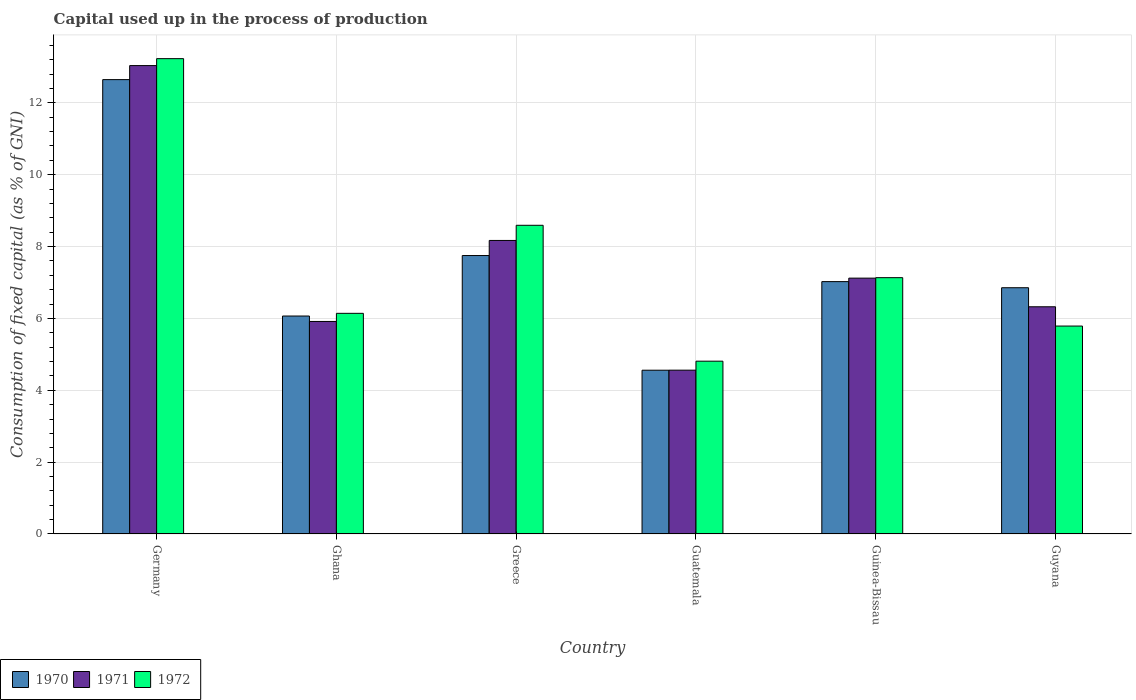How many groups of bars are there?
Offer a very short reply. 6. Are the number of bars per tick equal to the number of legend labels?
Give a very brief answer. Yes. Are the number of bars on each tick of the X-axis equal?
Provide a succinct answer. Yes. How many bars are there on the 2nd tick from the left?
Your answer should be compact. 3. How many bars are there on the 4th tick from the right?
Keep it short and to the point. 3. What is the label of the 5th group of bars from the left?
Your response must be concise. Guinea-Bissau. In how many cases, is the number of bars for a given country not equal to the number of legend labels?
Provide a short and direct response. 0. What is the capital used up in the process of production in 1970 in Germany?
Offer a terse response. 12.65. Across all countries, what is the maximum capital used up in the process of production in 1972?
Ensure brevity in your answer.  13.23. Across all countries, what is the minimum capital used up in the process of production in 1970?
Provide a succinct answer. 4.56. In which country was the capital used up in the process of production in 1970 minimum?
Make the answer very short. Guatemala. What is the total capital used up in the process of production in 1971 in the graph?
Ensure brevity in your answer.  45.13. What is the difference between the capital used up in the process of production in 1972 in Guinea-Bissau and that in Guyana?
Offer a very short reply. 1.35. What is the difference between the capital used up in the process of production in 1970 in Guyana and the capital used up in the process of production in 1972 in Guinea-Bissau?
Your response must be concise. -0.28. What is the average capital used up in the process of production in 1971 per country?
Offer a terse response. 7.52. What is the difference between the capital used up in the process of production of/in 1970 and capital used up in the process of production of/in 1972 in Ghana?
Your response must be concise. -0.07. What is the ratio of the capital used up in the process of production in 1971 in Germany to that in Guyana?
Offer a very short reply. 2.06. Is the difference between the capital used up in the process of production in 1970 in Greece and Guinea-Bissau greater than the difference between the capital used up in the process of production in 1972 in Greece and Guinea-Bissau?
Your response must be concise. No. What is the difference between the highest and the second highest capital used up in the process of production in 1970?
Keep it short and to the point. 5.62. What is the difference between the highest and the lowest capital used up in the process of production in 1972?
Make the answer very short. 8.42. Is the sum of the capital used up in the process of production in 1972 in Guinea-Bissau and Guyana greater than the maximum capital used up in the process of production in 1970 across all countries?
Your answer should be very brief. Yes. What does the 3rd bar from the left in Guinea-Bissau represents?
Keep it short and to the point. 1972. What does the 1st bar from the right in Guinea-Bissau represents?
Your answer should be compact. 1972. Is it the case that in every country, the sum of the capital used up in the process of production in 1970 and capital used up in the process of production in 1972 is greater than the capital used up in the process of production in 1971?
Keep it short and to the point. Yes. How many bars are there?
Make the answer very short. 18. What is the difference between two consecutive major ticks on the Y-axis?
Your answer should be compact. 2. Are the values on the major ticks of Y-axis written in scientific E-notation?
Make the answer very short. No. Does the graph contain any zero values?
Your answer should be very brief. No. Does the graph contain grids?
Make the answer very short. Yes. Where does the legend appear in the graph?
Your answer should be compact. Bottom left. What is the title of the graph?
Provide a short and direct response. Capital used up in the process of production. What is the label or title of the X-axis?
Provide a short and direct response. Country. What is the label or title of the Y-axis?
Your answer should be very brief. Consumption of fixed capital (as % of GNI). What is the Consumption of fixed capital (as % of GNI) of 1970 in Germany?
Make the answer very short. 12.65. What is the Consumption of fixed capital (as % of GNI) in 1971 in Germany?
Your response must be concise. 13.04. What is the Consumption of fixed capital (as % of GNI) of 1972 in Germany?
Give a very brief answer. 13.23. What is the Consumption of fixed capital (as % of GNI) of 1970 in Ghana?
Provide a succinct answer. 6.07. What is the Consumption of fixed capital (as % of GNI) of 1971 in Ghana?
Your response must be concise. 5.92. What is the Consumption of fixed capital (as % of GNI) of 1972 in Ghana?
Provide a short and direct response. 6.14. What is the Consumption of fixed capital (as % of GNI) in 1970 in Greece?
Offer a terse response. 7.75. What is the Consumption of fixed capital (as % of GNI) of 1971 in Greece?
Provide a succinct answer. 8.17. What is the Consumption of fixed capital (as % of GNI) of 1972 in Greece?
Give a very brief answer. 8.59. What is the Consumption of fixed capital (as % of GNI) in 1970 in Guatemala?
Offer a very short reply. 4.56. What is the Consumption of fixed capital (as % of GNI) in 1971 in Guatemala?
Ensure brevity in your answer.  4.56. What is the Consumption of fixed capital (as % of GNI) in 1972 in Guatemala?
Offer a very short reply. 4.81. What is the Consumption of fixed capital (as % of GNI) in 1970 in Guinea-Bissau?
Provide a succinct answer. 7.02. What is the Consumption of fixed capital (as % of GNI) in 1971 in Guinea-Bissau?
Offer a terse response. 7.12. What is the Consumption of fixed capital (as % of GNI) in 1972 in Guinea-Bissau?
Make the answer very short. 7.13. What is the Consumption of fixed capital (as % of GNI) of 1970 in Guyana?
Provide a succinct answer. 6.85. What is the Consumption of fixed capital (as % of GNI) in 1971 in Guyana?
Keep it short and to the point. 6.32. What is the Consumption of fixed capital (as % of GNI) in 1972 in Guyana?
Your answer should be compact. 5.79. Across all countries, what is the maximum Consumption of fixed capital (as % of GNI) of 1970?
Your response must be concise. 12.65. Across all countries, what is the maximum Consumption of fixed capital (as % of GNI) of 1971?
Offer a very short reply. 13.04. Across all countries, what is the maximum Consumption of fixed capital (as % of GNI) of 1972?
Offer a terse response. 13.23. Across all countries, what is the minimum Consumption of fixed capital (as % of GNI) in 1970?
Make the answer very short. 4.56. Across all countries, what is the minimum Consumption of fixed capital (as % of GNI) of 1971?
Ensure brevity in your answer.  4.56. Across all countries, what is the minimum Consumption of fixed capital (as % of GNI) of 1972?
Make the answer very short. 4.81. What is the total Consumption of fixed capital (as % of GNI) of 1970 in the graph?
Provide a short and direct response. 44.9. What is the total Consumption of fixed capital (as % of GNI) of 1971 in the graph?
Offer a very short reply. 45.13. What is the total Consumption of fixed capital (as % of GNI) in 1972 in the graph?
Your answer should be compact. 45.7. What is the difference between the Consumption of fixed capital (as % of GNI) in 1970 in Germany and that in Ghana?
Your answer should be very brief. 6.58. What is the difference between the Consumption of fixed capital (as % of GNI) in 1971 in Germany and that in Ghana?
Ensure brevity in your answer.  7.12. What is the difference between the Consumption of fixed capital (as % of GNI) of 1972 in Germany and that in Ghana?
Your answer should be very brief. 7.09. What is the difference between the Consumption of fixed capital (as % of GNI) of 1970 in Germany and that in Greece?
Offer a very short reply. 4.9. What is the difference between the Consumption of fixed capital (as % of GNI) in 1971 in Germany and that in Greece?
Ensure brevity in your answer.  4.87. What is the difference between the Consumption of fixed capital (as % of GNI) of 1972 in Germany and that in Greece?
Provide a short and direct response. 4.64. What is the difference between the Consumption of fixed capital (as % of GNI) of 1970 in Germany and that in Guatemala?
Ensure brevity in your answer.  8.09. What is the difference between the Consumption of fixed capital (as % of GNI) of 1971 in Germany and that in Guatemala?
Your answer should be compact. 8.48. What is the difference between the Consumption of fixed capital (as % of GNI) of 1972 in Germany and that in Guatemala?
Your response must be concise. 8.42. What is the difference between the Consumption of fixed capital (as % of GNI) of 1970 in Germany and that in Guinea-Bissau?
Your answer should be compact. 5.62. What is the difference between the Consumption of fixed capital (as % of GNI) in 1971 in Germany and that in Guinea-Bissau?
Your response must be concise. 5.92. What is the difference between the Consumption of fixed capital (as % of GNI) of 1972 in Germany and that in Guinea-Bissau?
Make the answer very short. 6.1. What is the difference between the Consumption of fixed capital (as % of GNI) in 1970 in Germany and that in Guyana?
Your answer should be compact. 5.79. What is the difference between the Consumption of fixed capital (as % of GNI) in 1971 in Germany and that in Guyana?
Your response must be concise. 6.71. What is the difference between the Consumption of fixed capital (as % of GNI) in 1972 in Germany and that in Guyana?
Your answer should be compact. 7.44. What is the difference between the Consumption of fixed capital (as % of GNI) of 1970 in Ghana and that in Greece?
Offer a terse response. -1.68. What is the difference between the Consumption of fixed capital (as % of GNI) of 1971 in Ghana and that in Greece?
Your response must be concise. -2.25. What is the difference between the Consumption of fixed capital (as % of GNI) of 1972 in Ghana and that in Greece?
Offer a terse response. -2.45. What is the difference between the Consumption of fixed capital (as % of GNI) of 1970 in Ghana and that in Guatemala?
Ensure brevity in your answer.  1.51. What is the difference between the Consumption of fixed capital (as % of GNI) of 1971 in Ghana and that in Guatemala?
Keep it short and to the point. 1.36. What is the difference between the Consumption of fixed capital (as % of GNI) of 1972 in Ghana and that in Guatemala?
Provide a short and direct response. 1.33. What is the difference between the Consumption of fixed capital (as % of GNI) of 1970 in Ghana and that in Guinea-Bissau?
Offer a terse response. -0.96. What is the difference between the Consumption of fixed capital (as % of GNI) in 1971 in Ghana and that in Guinea-Bissau?
Provide a short and direct response. -1.21. What is the difference between the Consumption of fixed capital (as % of GNI) in 1972 in Ghana and that in Guinea-Bissau?
Give a very brief answer. -0.99. What is the difference between the Consumption of fixed capital (as % of GNI) of 1970 in Ghana and that in Guyana?
Make the answer very short. -0.79. What is the difference between the Consumption of fixed capital (as % of GNI) of 1971 in Ghana and that in Guyana?
Keep it short and to the point. -0.41. What is the difference between the Consumption of fixed capital (as % of GNI) in 1972 in Ghana and that in Guyana?
Offer a very short reply. 0.35. What is the difference between the Consumption of fixed capital (as % of GNI) of 1970 in Greece and that in Guatemala?
Your answer should be very brief. 3.19. What is the difference between the Consumption of fixed capital (as % of GNI) in 1971 in Greece and that in Guatemala?
Offer a terse response. 3.61. What is the difference between the Consumption of fixed capital (as % of GNI) of 1972 in Greece and that in Guatemala?
Provide a short and direct response. 3.78. What is the difference between the Consumption of fixed capital (as % of GNI) in 1970 in Greece and that in Guinea-Bissau?
Make the answer very short. 0.73. What is the difference between the Consumption of fixed capital (as % of GNI) in 1971 in Greece and that in Guinea-Bissau?
Your answer should be very brief. 1.05. What is the difference between the Consumption of fixed capital (as % of GNI) of 1972 in Greece and that in Guinea-Bissau?
Give a very brief answer. 1.46. What is the difference between the Consumption of fixed capital (as % of GNI) in 1970 in Greece and that in Guyana?
Offer a very short reply. 0.9. What is the difference between the Consumption of fixed capital (as % of GNI) of 1971 in Greece and that in Guyana?
Provide a short and direct response. 1.85. What is the difference between the Consumption of fixed capital (as % of GNI) in 1972 in Greece and that in Guyana?
Your response must be concise. 2.81. What is the difference between the Consumption of fixed capital (as % of GNI) in 1970 in Guatemala and that in Guinea-Bissau?
Ensure brevity in your answer.  -2.47. What is the difference between the Consumption of fixed capital (as % of GNI) in 1971 in Guatemala and that in Guinea-Bissau?
Keep it short and to the point. -2.56. What is the difference between the Consumption of fixed capital (as % of GNI) of 1972 in Guatemala and that in Guinea-Bissau?
Offer a very short reply. -2.33. What is the difference between the Consumption of fixed capital (as % of GNI) in 1970 in Guatemala and that in Guyana?
Ensure brevity in your answer.  -2.3. What is the difference between the Consumption of fixed capital (as % of GNI) of 1971 in Guatemala and that in Guyana?
Provide a succinct answer. -1.76. What is the difference between the Consumption of fixed capital (as % of GNI) in 1972 in Guatemala and that in Guyana?
Give a very brief answer. -0.98. What is the difference between the Consumption of fixed capital (as % of GNI) in 1970 in Guinea-Bissau and that in Guyana?
Your answer should be very brief. 0.17. What is the difference between the Consumption of fixed capital (as % of GNI) of 1971 in Guinea-Bissau and that in Guyana?
Make the answer very short. 0.8. What is the difference between the Consumption of fixed capital (as % of GNI) of 1972 in Guinea-Bissau and that in Guyana?
Your response must be concise. 1.35. What is the difference between the Consumption of fixed capital (as % of GNI) of 1970 in Germany and the Consumption of fixed capital (as % of GNI) of 1971 in Ghana?
Offer a terse response. 6.73. What is the difference between the Consumption of fixed capital (as % of GNI) of 1970 in Germany and the Consumption of fixed capital (as % of GNI) of 1972 in Ghana?
Offer a terse response. 6.51. What is the difference between the Consumption of fixed capital (as % of GNI) of 1971 in Germany and the Consumption of fixed capital (as % of GNI) of 1972 in Ghana?
Your answer should be very brief. 6.9. What is the difference between the Consumption of fixed capital (as % of GNI) of 1970 in Germany and the Consumption of fixed capital (as % of GNI) of 1971 in Greece?
Provide a short and direct response. 4.48. What is the difference between the Consumption of fixed capital (as % of GNI) in 1970 in Germany and the Consumption of fixed capital (as % of GNI) in 1972 in Greece?
Make the answer very short. 4.05. What is the difference between the Consumption of fixed capital (as % of GNI) of 1971 in Germany and the Consumption of fixed capital (as % of GNI) of 1972 in Greece?
Your answer should be compact. 4.45. What is the difference between the Consumption of fixed capital (as % of GNI) of 1970 in Germany and the Consumption of fixed capital (as % of GNI) of 1971 in Guatemala?
Provide a short and direct response. 8.09. What is the difference between the Consumption of fixed capital (as % of GNI) of 1970 in Germany and the Consumption of fixed capital (as % of GNI) of 1972 in Guatemala?
Offer a terse response. 7.84. What is the difference between the Consumption of fixed capital (as % of GNI) in 1971 in Germany and the Consumption of fixed capital (as % of GNI) in 1972 in Guatemala?
Provide a succinct answer. 8.23. What is the difference between the Consumption of fixed capital (as % of GNI) in 1970 in Germany and the Consumption of fixed capital (as % of GNI) in 1971 in Guinea-Bissau?
Provide a succinct answer. 5.53. What is the difference between the Consumption of fixed capital (as % of GNI) in 1970 in Germany and the Consumption of fixed capital (as % of GNI) in 1972 in Guinea-Bissau?
Your response must be concise. 5.51. What is the difference between the Consumption of fixed capital (as % of GNI) of 1971 in Germany and the Consumption of fixed capital (as % of GNI) of 1972 in Guinea-Bissau?
Make the answer very short. 5.9. What is the difference between the Consumption of fixed capital (as % of GNI) in 1970 in Germany and the Consumption of fixed capital (as % of GNI) in 1971 in Guyana?
Give a very brief answer. 6.32. What is the difference between the Consumption of fixed capital (as % of GNI) in 1970 in Germany and the Consumption of fixed capital (as % of GNI) in 1972 in Guyana?
Ensure brevity in your answer.  6.86. What is the difference between the Consumption of fixed capital (as % of GNI) in 1971 in Germany and the Consumption of fixed capital (as % of GNI) in 1972 in Guyana?
Offer a very short reply. 7.25. What is the difference between the Consumption of fixed capital (as % of GNI) in 1970 in Ghana and the Consumption of fixed capital (as % of GNI) in 1971 in Greece?
Ensure brevity in your answer.  -2.1. What is the difference between the Consumption of fixed capital (as % of GNI) of 1970 in Ghana and the Consumption of fixed capital (as % of GNI) of 1972 in Greece?
Offer a very short reply. -2.53. What is the difference between the Consumption of fixed capital (as % of GNI) of 1971 in Ghana and the Consumption of fixed capital (as % of GNI) of 1972 in Greece?
Your answer should be very brief. -2.68. What is the difference between the Consumption of fixed capital (as % of GNI) of 1970 in Ghana and the Consumption of fixed capital (as % of GNI) of 1971 in Guatemala?
Give a very brief answer. 1.51. What is the difference between the Consumption of fixed capital (as % of GNI) of 1970 in Ghana and the Consumption of fixed capital (as % of GNI) of 1972 in Guatemala?
Your answer should be compact. 1.26. What is the difference between the Consumption of fixed capital (as % of GNI) of 1971 in Ghana and the Consumption of fixed capital (as % of GNI) of 1972 in Guatemala?
Ensure brevity in your answer.  1.11. What is the difference between the Consumption of fixed capital (as % of GNI) of 1970 in Ghana and the Consumption of fixed capital (as % of GNI) of 1971 in Guinea-Bissau?
Your answer should be compact. -1.05. What is the difference between the Consumption of fixed capital (as % of GNI) of 1970 in Ghana and the Consumption of fixed capital (as % of GNI) of 1972 in Guinea-Bissau?
Make the answer very short. -1.07. What is the difference between the Consumption of fixed capital (as % of GNI) of 1971 in Ghana and the Consumption of fixed capital (as % of GNI) of 1972 in Guinea-Bissau?
Your answer should be compact. -1.22. What is the difference between the Consumption of fixed capital (as % of GNI) of 1970 in Ghana and the Consumption of fixed capital (as % of GNI) of 1971 in Guyana?
Offer a terse response. -0.26. What is the difference between the Consumption of fixed capital (as % of GNI) of 1970 in Ghana and the Consumption of fixed capital (as % of GNI) of 1972 in Guyana?
Your answer should be very brief. 0.28. What is the difference between the Consumption of fixed capital (as % of GNI) of 1971 in Ghana and the Consumption of fixed capital (as % of GNI) of 1972 in Guyana?
Your answer should be compact. 0.13. What is the difference between the Consumption of fixed capital (as % of GNI) of 1970 in Greece and the Consumption of fixed capital (as % of GNI) of 1971 in Guatemala?
Your response must be concise. 3.19. What is the difference between the Consumption of fixed capital (as % of GNI) in 1970 in Greece and the Consumption of fixed capital (as % of GNI) in 1972 in Guatemala?
Offer a very short reply. 2.94. What is the difference between the Consumption of fixed capital (as % of GNI) of 1971 in Greece and the Consumption of fixed capital (as % of GNI) of 1972 in Guatemala?
Provide a succinct answer. 3.36. What is the difference between the Consumption of fixed capital (as % of GNI) of 1970 in Greece and the Consumption of fixed capital (as % of GNI) of 1971 in Guinea-Bissau?
Give a very brief answer. 0.63. What is the difference between the Consumption of fixed capital (as % of GNI) of 1970 in Greece and the Consumption of fixed capital (as % of GNI) of 1972 in Guinea-Bissau?
Your answer should be very brief. 0.62. What is the difference between the Consumption of fixed capital (as % of GNI) in 1971 in Greece and the Consumption of fixed capital (as % of GNI) in 1972 in Guinea-Bissau?
Provide a succinct answer. 1.04. What is the difference between the Consumption of fixed capital (as % of GNI) in 1970 in Greece and the Consumption of fixed capital (as % of GNI) in 1971 in Guyana?
Ensure brevity in your answer.  1.43. What is the difference between the Consumption of fixed capital (as % of GNI) of 1970 in Greece and the Consumption of fixed capital (as % of GNI) of 1972 in Guyana?
Give a very brief answer. 1.96. What is the difference between the Consumption of fixed capital (as % of GNI) of 1971 in Greece and the Consumption of fixed capital (as % of GNI) of 1972 in Guyana?
Provide a short and direct response. 2.38. What is the difference between the Consumption of fixed capital (as % of GNI) of 1970 in Guatemala and the Consumption of fixed capital (as % of GNI) of 1971 in Guinea-Bissau?
Offer a terse response. -2.56. What is the difference between the Consumption of fixed capital (as % of GNI) in 1970 in Guatemala and the Consumption of fixed capital (as % of GNI) in 1972 in Guinea-Bissau?
Offer a terse response. -2.58. What is the difference between the Consumption of fixed capital (as % of GNI) of 1971 in Guatemala and the Consumption of fixed capital (as % of GNI) of 1972 in Guinea-Bissau?
Offer a very short reply. -2.57. What is the difference between the Consumption of fixed capital (as % of GNI) of 1970 in Guatemala and the Consumption of fixed capital (as % of GNI) of 1971 in Guyana?
Offer a very short reply. -1.77. What is the difference between the Consumption of fixed capital (as % of GNI) of 1970 in Guatemala and the Consumption of fixed capital (as % of GNI) of 1972 in Guyana?
Give a very brief answer. -1.23. What is the difference between the Consumption of fixed capital (as % of GNI) of 1971 in Guatemala and the Consumption of fixed capital (as % of GNI) of 1972 in Guyana?
Make the answer very short. -1.23. What is the difference between the Consumption of fixed capital (as % of GNI) in 1970 in Guinea-Bissau and the Consumption of fixed capital (as % of GNI) in 1971 in Guyana?
Your answer should be compact. 0.7. What is the difference between the Consumption of fixed capital (as % of GNI) in 1970 in Guinea-Bissau and the Consumption of fixed capital (as % of GNI) in 1972 in Guyana?
Offer a very short reply. 1.24. What is the difference between the Consumption of fixed capital (as % of GNI) in 1971 in Guinea-Bissau and the Consumption of fixed capital (as % of GNI) in 1972 in Guyana?
Make the answer very short. 1.33. What is the average Consumption of fixed capital (as % of GNI) of 1970 per country?
Provide a short and direct response. 7.48. What is the average Consumption of fixed capital (as % of GNI) in 1971 per country?
Your response must be concise. 7.52. What is the average Consumption of fixed capital (as % of GNI) of 1972 per country?
Your answer should be compact. 7.62. What is the difference between the Consumption of fixed capital (as % of GNI) in 1970 and Consumption of fixed capital (as % of GNI) in 1971 in Germany?
Give a very brief answer. -0.39. What is the difference between the Consumption of fixed capital (as % of GNI) of 1970 and Consumption of fixed capital (as % of GNI) of 1972 in Germany?
Provide a succinct answer. -0.58. What is the difference between the Consumption of fixed capital (as % of GNI) in 1971 and Consumption of fixed capital (as % of GNI) in 1972 in Germany?
Your response must be concise. -0.19. What is the difference between the Consumption of fixed capital (as % of GNI) in 1970 and Consumption of fixed capital (as % of GNI) in 1971 in Ghana?
Provide a short and direct response. 0.15. What is the difference between the Consumption of fixed capital (as % of GNI) in 1970 and Consumption of fixed capital (as % of GNI) in 1972 in Ghana?
Your answer should be compact. -0.07. What is the difference between the Consumption of fixed capital (as % of GNI) of 1971 and Consumption of fixed capital (as % of GNI) of 1972 in Ghana?
Keep it short and to the point. -0.23. What is the difference between the Consumption of fixed capital (as % of GNI) of 1970 and Consumption of fixed capital (as % of GNI) of 1971 in Greece?
Provide a succinct answer. -0.42. What is the difference between the Consumption of fixed capital (as % of GNI) in 1970 and Consumption of fixed capital (as % of GNI) in 1972 in Greece?
Your answer should be compact. -0.84. What is the difference between the Consumption of fixed capital (as % of GNI) in 1971 and Consumption of fixed capital (as % of GNI) in 1972 in Greece?
Your answer should be compact. -0.42. What is the difference between the Consumption of fixed capital (as % of GNI) in 1970 and Consumption of fixed capital (as % of GNI) in 1971 in Guatemala?
Keep it short and to the point. -0. What is the difference between the Consumption of fixed capital (as % of GNI) in 1970 and Consumption of fixed capital (as % of GNI) in 1972 in Guatemala?
Your answer should be very brief. -0.25. What is the difference between the Consumption of fixed capital (as % of GNI) of 1971 and Consumption of fixed capital (as % of GNI) of 1972 in Guatemala?
Offer a very short reply. -0.25. What is the difference between the Consumption of fixed capital (as % of GNI) of 1970 and Consumption of fixed capital (as % of GNI) of 1971 in Guinea-Bissau?
Provide a short and direct response. -0.1. What is the difference between the Consumption of fixed capital (as % of GNI) in 1970 and Consumption of fixed capital (as % of GNI) in 1972 in Guinea-Bissau?
Offer a very short reply. -0.11. What is the difference between the Consumption of fixed capital (as % of GNI) of 1971 and Consumption of fixed capital (as % of GNI) of 1972 in Guinea-Bissau?
Your response must be concise. -0.01. What is the difference between the Consumption of fixed capital (as % of GNI) of 1970 and Consumption of fixed capital (as % of GNI) of 1971 in Guyana?
Offer a very short reply. 0.53. What is the difference between the Consumption of fixed capital (as % of GNI) in 1970 and Consumption of fixed capital (as % of GNI) in 1972 in Guyana?
Offer a very short reply. 1.07. What is the difference between the Consumption of fixed capital (as % of GNI) of 1971 and Consumption of fixed capital (as % of GNI) of 1972 in Guyana?
Offer a terse response. 0.54. What is the ratio of the Consumption of fixed capital (as % of GNI) of 1970 in Germany to that in Ghana?
Keep it short and to the point. 2.08. What is the ratio of the Consumption of fixed capital (as % of GNI) in 1971 in Germany to that in Ghana?
Make the answer very short. 2.2. What is the ratio of the Consumption of fixed capital (as % of GNI) of 1972 in Germany to that in Ghana?
Provide a short and direct response. 2.15. What is the ratio of the Consumption of fixed capital (as % of GNI) in 1970 in Germany to that in Greece?
Your answer should be very brief. 1.63. What is the ratio of the Consumption of fixed capital (as % of GNI) of 1971 in Germany to that in Greece?
Keep it short and to the point. 1.6. What is the ratio of the Consumption of fixed capital (as % of GNI) of 1972 in Germany to that in Greece?
Your answer should be very brief. 1.54. What is the ratio of the Consumption of fixed capital (as % of GNI) in 1970 in Germany to that in Guatemala?
Offer a terse response. 2.77. What is the ratio of the Consumption of fixed capital (as % of GNI) in 1971 in Germany to that in Guatemala?
Keep it short and to the point. 2.86. What is the ratio of the Consumption of fixed capital (as % of GNI) of 1972 in Germany to that in Guatemala?
Your answer should be very brief. 2.75. What is the ratio of the Consumption of fixed capital (as % of GNI) of 1970 in Germany to that in Guinea-Bissau?
Make the answer very short. 1.8. What is the ratio of the Consumption of fixed capital (as % of GNI) of 1971 in Germany to that in Guinea-Bissau?
Give a very brief answer. 1.83. What is the ratio of the Consumption of fixed capital (as % of GNI) in 1972 in Germany to that in Guinea-Bissau?
Your response must be concise. 1.85. What is the ratio of the Consumption of fixed capital (as % of GNI) of 1970 in Germany to that in Guyana?
Ensure brevity in your answer.  1.85. What is the ratio of the Consumption of fixed capital (as % of GNI) of 1971 in Germany to that in Guyana?
Offer a very short reply. 2.06. What is the ratio of the Consumption of fixed capital (as % of GNI) of 1972 in Germany to that in Guyana?
Provide a short and direct response. 2.29. What is the ratio of the Consumption of fixed capital (as % of GNI) of 1970 in Ghana to that in Greece?
Offer a very short reply. 0.78. What is the ratio of the Consumption of fixed capital (as % of GNI) of 1971 in Ghana to that in Greece?
Your answer should be compact. 0.72. What is the ratio of the Consumption of fixed capital (as % of GNI) in 1972 in Ghana to that in Greece?
Offer a very short reply. 0.71. What is the ratio of the Consumption of fixed capital (as % of GNI) in 1970 in Ghana to that in Guatemala?
Your answer should be very brief. 1.33. What is the ratio of the Consumption of fixed capital (as % of GNI) of 1971 in Ghana to that in Guatemala?
Provide a succinct answer. 1.3. What is the ratio of the Consumption of fixed capital (as % of GNI) of 1972 in Ghana to that in Guatemala?
Provide a short and direct response. 1.28. What is the ratio of the Consumption of fixed capital (as % of GNI) in 1970 in Ghana to that in Guinea-Bissau?
Give a very brief answer. 0.86. What is the ratio of the Consumption of fixed capital (as % of GNI) of 1971 in Ghana to that in Guinea-Bissau?
Make the answer very short. 0.83. What is the ratio of the Consumption of fixed capital (as % of GNI) in 1972 in Ghana to that in Guinea-Bissau?
Offer a terse response. 0.86. What is the ratio of the Consumption of fixed capital (as % of GNI) in 1970 in Ghana to that in Guyana?
Your answer should be very brief. 0.89. What is the ratio of the Consumption of fixed capital (as % of GNI) of 1971 in Ghana to that in Guyana?
Keep it short and to the point. 0.94. What is the ratio of the Consumption of fixed capital (as % of GNI) of 1972 in Ghana to that in Guyana?
Make the answer very short. 1.06. What is the ratio of the Consumption of fixed capital (as % of GNI) of 1970 in Greece to that in Guatemala?
Give a very brief answer. 1.7. What is the ratio of the Consumption of fixed capital (as % of GNI) of 1971 in Greece to that in Guatemala?
Your answer should be very brief. 1.79. What is the ratio of the Consumption of fixed capital (as % of GNI) of 1972 in Greece to that in Guatemala?
Ensure brevity in your answer.  1.79. What is the ratio of the Consumption of fixed capital (as % of GNI) of 1970 in Greece to that in Guinea-Bissau?
Your answer should be very brief. 1.1. What is the ratio of the Consumption of fixed capital (as % of GNI) of 1971 in Greece to that in Guinea-Bissau?
Offer a terse response. 1.15. What is the ratio of the Consumption of fixed capital (as % of GNI) in 1972 in Greece to that in Guinea-Bissau?
Offer a very short reply. 1.2. What is the ratio of the Consumption of fixed capital (as % of GNI) in 1970 in Greece to that in Guyana?
Keep it short and to the point. 1.13. What is the ratio of the Consumption of fixed capital (as % of GNI) of 1971 in Greece to that in Guyana?
Keep it short and to the point. 1.29. What is the ratio of the Consumption of fixed capital (as % of GNI) in 1972 in Greece to that in Guyana?
Your answer should be compact. 1.48. What is the ratio of the Consumption of fixed capital (as % of GNI) of 1970 in Guatemala to that in Guinea-Bissau?
Make the answer very short. 0.65. What is the ratio of the Consumption of fixed capital (as % of GNI) of 1971 in Guatemala to that in Guinea-Bissau?
Offer a terse response. 0.64. What is the ratio of the Consumption of fixed capital (as % of GNI) of 1972 in Guatemala to that in Guinea-Bissau?
Make the answer very short. 0.67. What is the ratio of the Consumption of fixed capital (as % of GNI) in 1970 in Guatemala to that in Guyana?
Provide a succinct answer. 0.67. What is the ratio of the Consumption of fixed capital (as % of GNI) of 1971 in Guatemala to that in Guyana?
Provide a short and direct response. 0.72. What is the ratio of the Consumption of fixed capital (as % of GNI) of 1972 in Guatemala to that in Guyana?
Your answer should be very brief. 0.83. What is the ratio of the Consumption of fixed capital (as % of GNI) in 1970 in Guinea-Bissau to that in Guyana?
Your answer should be compact. 1.02. What is the ratio of the Consumption of fixed capital (as % of GNI) of 1971 in Guinea-Bissau to that in Guyana?
Keep it short and to the point. 1.13. What is the ratio of the Consumption of fixed capital (as % of GNI) in 1972 in Guinea-Bissau to that in Guyana?
Provide a succinct answer. 1.23. What is the difference between the highest and the second highest Consumption of fixed capital (as % of GNI) of 1970?
Ensure brevity in your answer.  4.9. What is the difference between the highest and the second highest Consumption of fixed capital (as % of GNI) in 1971?
Your response must be concise. 4.87. What is the difference between the highest and the second highest Consumption of fixed capital (as % of GNI) of 1972?
Your answer should be compact. 4.64. What is the difference between the highest and the lowest Consumption of fixed capital (as % of GNI) of 1970?
Provide a succinct answer. 8.09. What is the difference between the highest and the lowest Consumption of fixed capital (as % of GNI) of 1971?
Keep it short and to the point. 8.48. What is the difference between the highest and the lowest Consumption of fixed capital (as % of GNI) in 1972?
Your answer should be very brief. 8.42. 